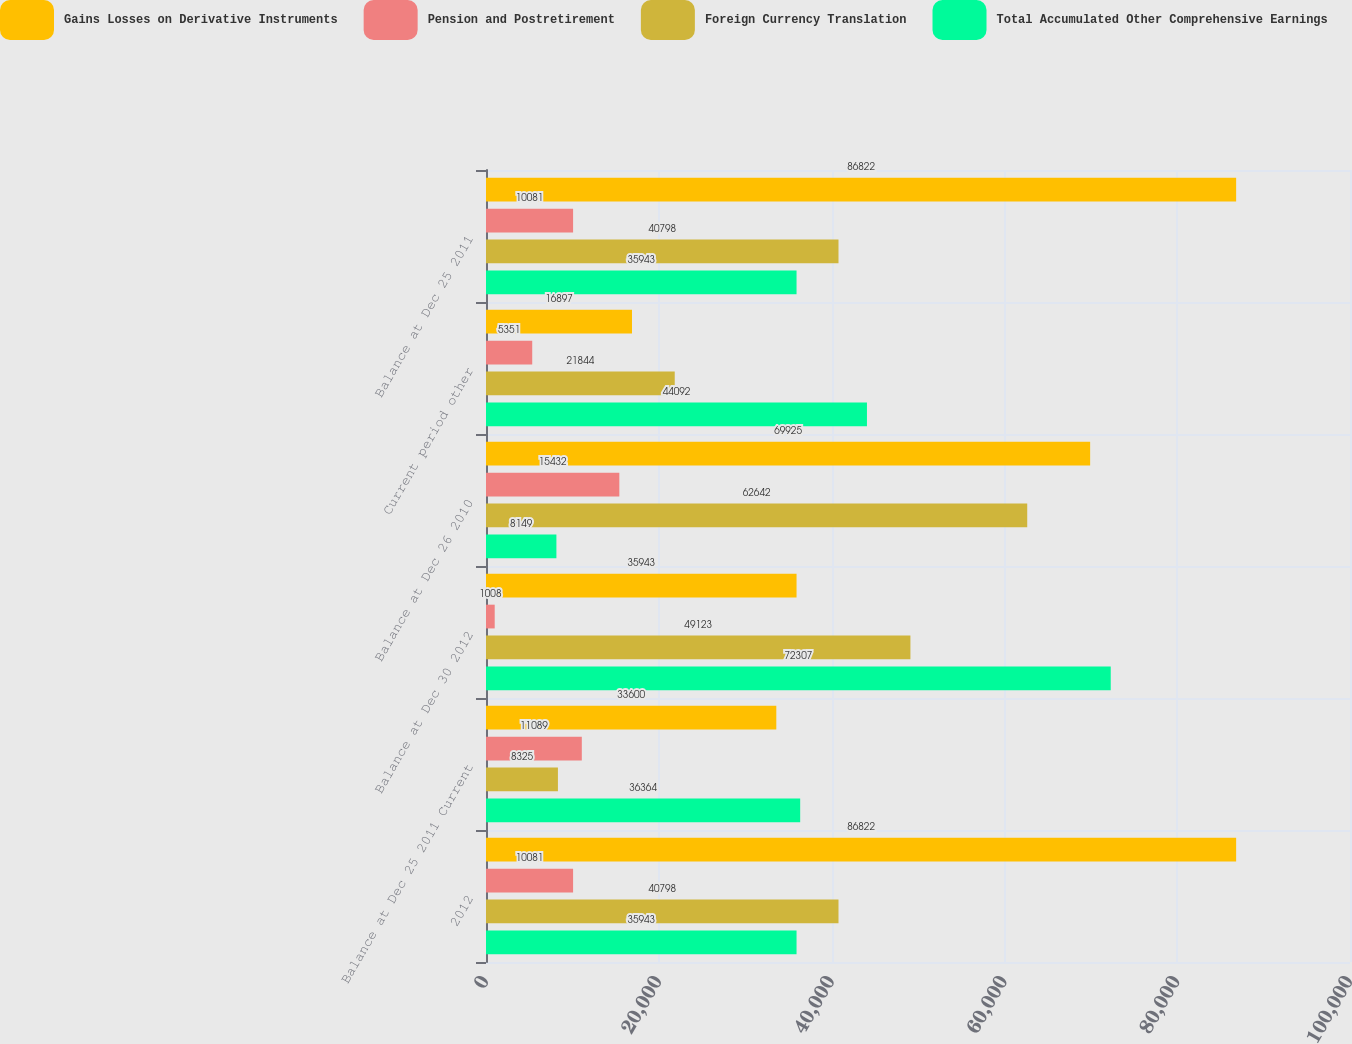Convert chart to OTSL. <chart><loc_0><loc_0><loc_500><loc_500><stacked_bar_chart><ecel><fcel>2012<fcel>Balance at Dec 25 2011 Current<fcel>Balance at Dec 30 2012<fcel>Balance at Dec 26 2010<fcel>Current period other<fcel>Balance at Dec 25 2011<nl><fcel>Gains Losses on Derivative Instruments<fcel>86822<fcel>33600<fcel>35943<fcel>69925<fcel>16897<fcel>86822<nl><fcel>Pension and Postretirement<fcel>10081<fcel>11089<fcel>1008<fcel>15432<fcel>5351<fcel>10081<nl><fcel>Foreign Currency Translation<fcel>40798<fcel>8325<fcel>49123<fcel>62642<fcel>21844<fcel>40798<nl><fcel>Total Accumulated Other Comprehensive Earnings<fcel>35943<fcel>36364<fcel>72307<fcel>8149<fcel>44092<fcel>35943<nl></chart> 